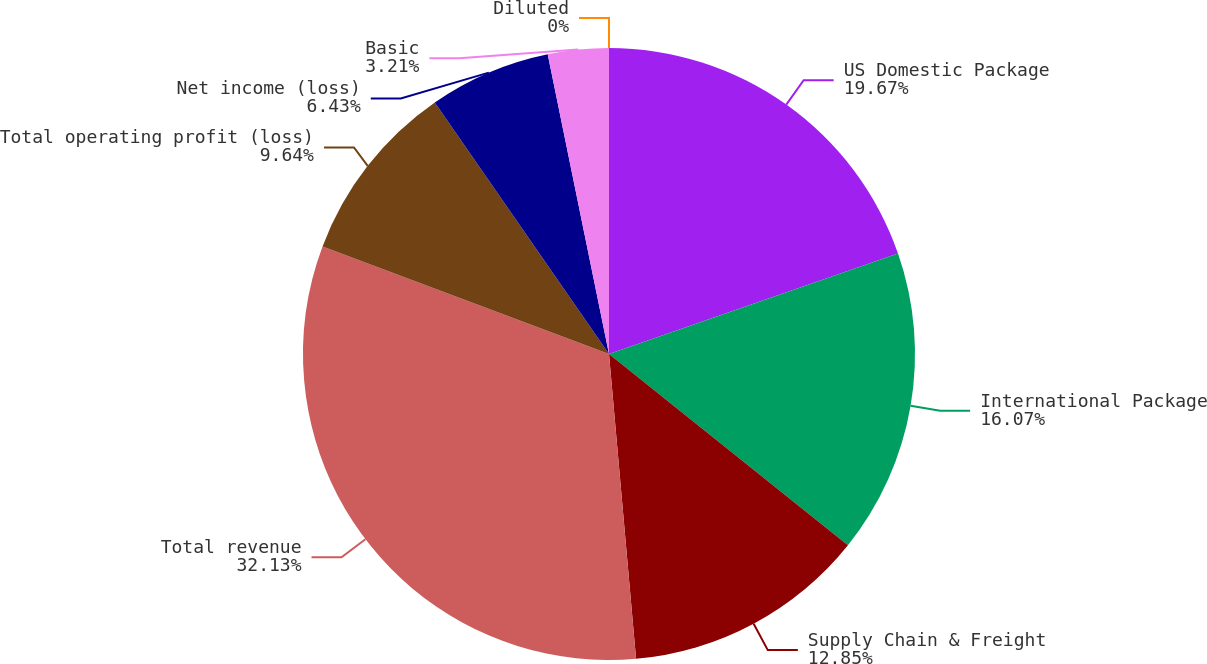Convert chart. <chart><loc_0><loc_0><loc_500><loc_500><pie_chart><fcel>US Domestic Package<fcel>International Package<fcel>Supply Chain & Freight<fcel>Total revenue<fcel>Total operating profit (loss)<fcel>Net income (loss)<fcel>Basic<fcel>Diluted<nl><fcel>19.67%<fcel>16.07%<fcel>12.85%<fcel>32.13%<fcel>9.64%<fcel>6.43%<fcel>3.21%<fcel>0.0%<nl></chart> 